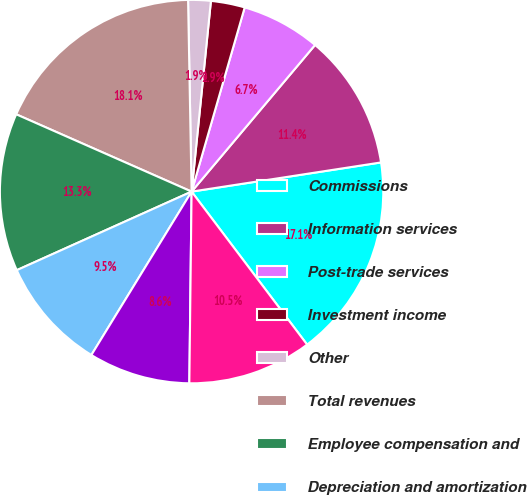Convert chart. <chart><loc_0><loc_0><loc_500><loc_500><pie_chart><fcel>Commissions<fcel>Information services<fcel>Post-trade services<fcel>Investment income<fcel>Other<fcel>Total revenues<fcel>Employee compensation and<fcel>Depreciation and amortization<fcel>Technology and communications<fcel>Professional and consulting<nl><fcel>17.14%<fcel>11.43%<fcel>6.67%<fcel>2.86%<fcel>1.9%<fcel>18.1%<fcel>13.33%<fcel>9.52%<fcel>8.57%<fcel>10.48%<nl></chart> 